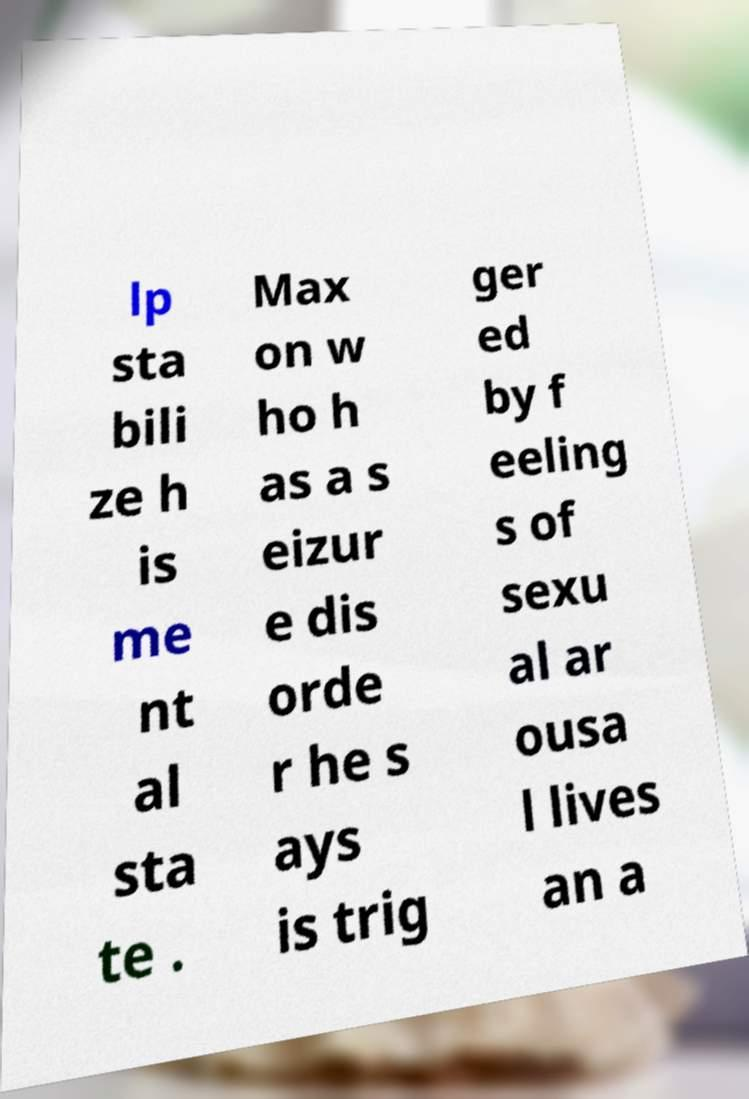Could you assist in decoding the text presented in this image and type it out clearly? lp sta bili ze h is me nt al sta te . Max on w ho h as a s eizur e dis orde r he s ays is trig ger ed by f eeling s of sexu al ar ousa l lives an a 